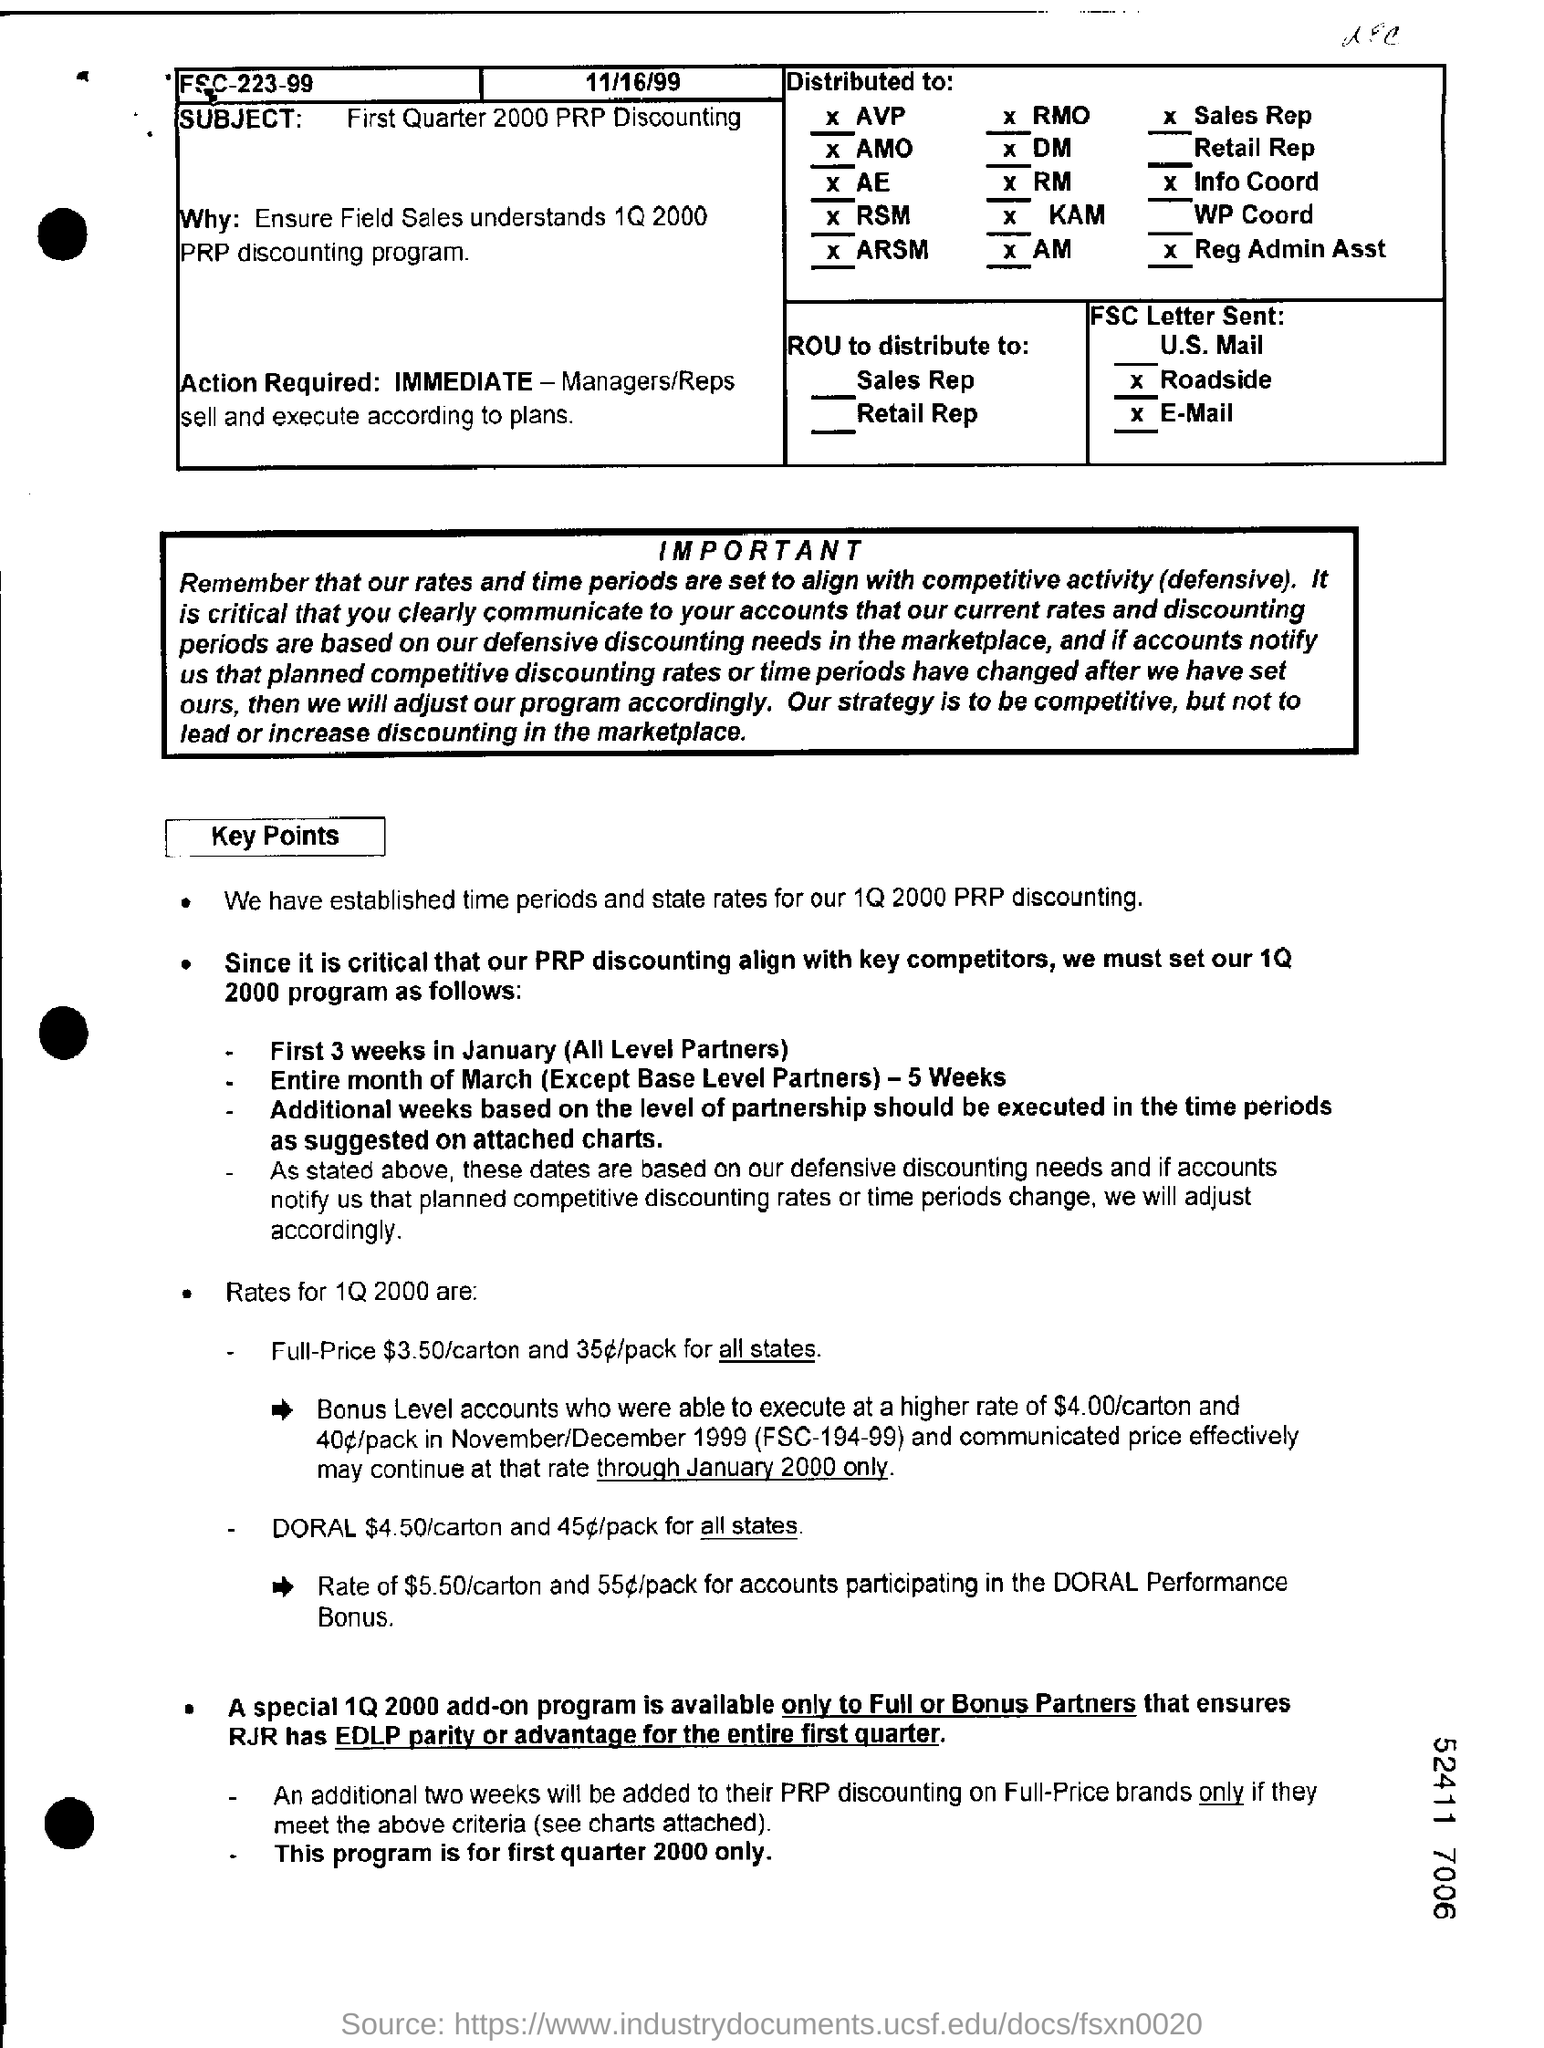Indicate a few pertinent items in this graphic. This special 1Q 2000 add-on program is only available to Full or Bonus Partners. It is necessary to take immediate action. The subject of the document is "First Quarter 2000 PRP Discounting. 